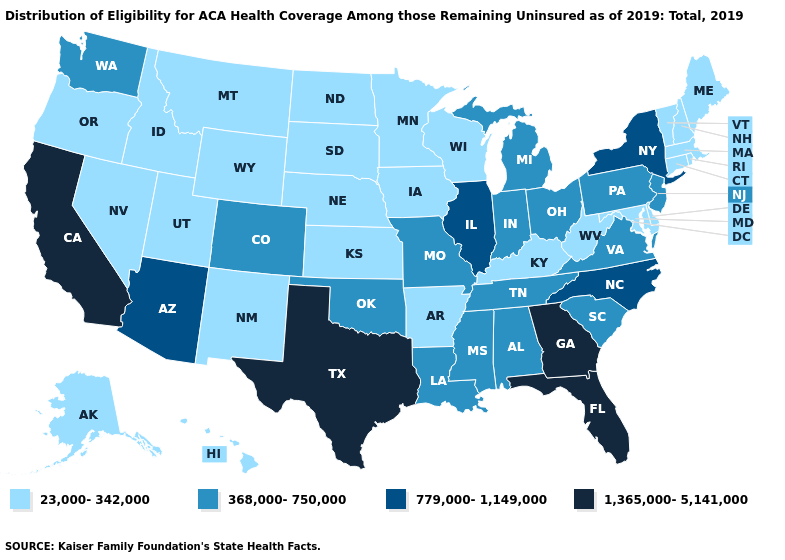Does the map have missing data?
Write a very short answer. No. Name the states that have a value in the range 368,000-750,000?
Short answer required. Alabama, Colorado, Indiana, Louisiana, Michigan, Mississippi, Missouri, New Jersey, Ohio, Oklahoma, Pennsylvania, South Carolina, Tennessee, Virginia, Washington. What is the highest value in the South ?
Keep it brief. 1,365,000-5,141,000. Name the states that have a value in the range 1,365,000-5,141,000?
Quick response, please. California, Florida, Georgia, Texas. Name the states that have a value in the range 368,000-750,000?
Be succinct. Alabama, Colorado, Indiana, Louisiana, Michigan, Mississippi, Missouri, New Jersey, Ohio, Oklahoma, Pennsylvania, South Carolina, Tennessee, Virginia, Washington. Name the states that have a value in the range 368,000-750,000?
Give a very brief answer. Alabama, Colorado, Indiana, Louisiana, Michigan, Mississippi, Missouri, New Jersey, Ohio, Oklahoma, Pennsylvania, South Carolina, Tennessee, Virginia, Washington. Does New Jersey have a higher value than North Dakota?
Answer briefly. Yes. Name the states that have a value in the range 23,000-342,000?
Give a very brief answer. Alaska, Arkansas, Connecticut, Delaware, Hawaii, Idaho, Iowa, Kansas, Kentucky, Maine, Maryland, Massachusetts, Minnesota, Montana, Nebraska, Nevada, New Hampshire, New Mexico, North Dakota, Oregon, Rhode Island, South Dakota, Utah, Vermont, West Virginia, Wisconsin, Wyoming. Name the states that have a value in the range 23,000-342,000?
Keep it brief. Alaska, Arkansas, Connecticut, Delaware, Hawaii, Idaho, Iowa, Kansas, Kentucky, Maine, Maryland, Massachusetts, Minnesota, Montana, Nebraska, Nevada, New Hampshire, New Mexico, North Dakota, Oregon, Rhode Island, South Dakota, Utah, Vermont, West Virginia, Wisconsin, Wyoming. How many symbols are there in the legend?
Give a very brief answer. 4. What is the highest value in the USA?
Write a very short answer. 1,365,000-5,141,000. Among the states that border Michigan , does Indiana have the highest value?
Short answer required. Yes. Does Arizona have a higher value than California?
Keep it brief. No. Does South Carolina have the highest value in the South?
Be succinct. No. Name the states that have a value in the range 23,000-342,000?
Answer briefly. Alaska, Arkansas, Connecticut, Delaware, Hawaii, Idaho, Iowa, Kansas, Kentucky, Maine, Maryland, Massachusetts, Minnesota, Montana, Nebraska, Nevada, New Hampshire, New Mexico, North Dakota, Oregon, Rhode Island, South Dakota, Utah, Vermont, West Virginia, Wisconsin, Wyoming. 